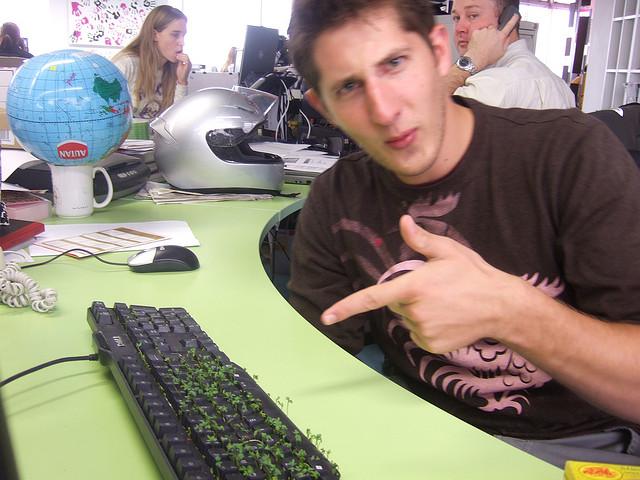What is the round thing behind the man?
Give a very brief answer. Globe. What is coming out of this man's keyboard?
Give a very brief answer. Plants. Is the man wearing a watch?
Be succinct. No. How many watches are in the picture?
Concise answer only. 1. 